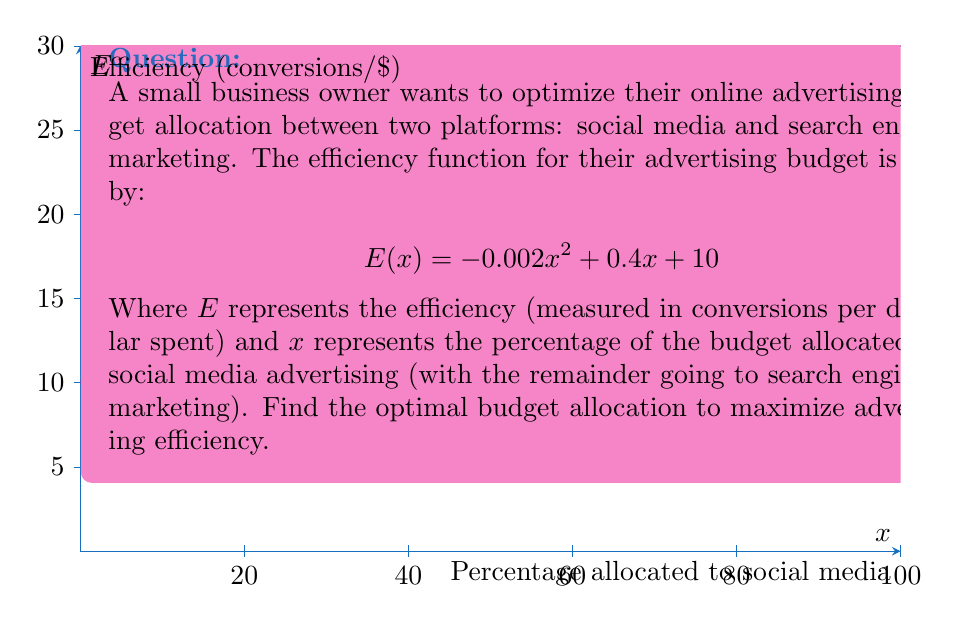Give your solution to this math problem. To find the maximum efficiency point, we need to find the vertex of the parabola described by the efficiency function. We can do this by following these steps:

1) The efficiency function is in the form of a quadratic equation:
   $$E(x) = -0.002x^2 + 0.4x + 10$$

2) For a quadratic function in the form $f(x) = ax^2 + bx + c$, the x-coordinate of the vertex is given by $x = -\frac{b}{2a}$.

3) In our case:
   $a = -0.002$
   $b = 0.4$

4) Plugging these values into the formula:
   $$x = -\frac{0.4}{2(-0.002)} = -\frac{0.4}{-0.004} = 100$$

5) This means the efficiency is maximized when 100% of the budget is allocated to social media advertising.

6) To verify, we can calculate the second derivative:
   $$E'(x) = -0.004x + 0.4$$
   $$E''(x) = -0.004$$

   Since $E''(x)$ is negative, this confirms we've found a maximum.

7) The maximum efficiency can be calculated by plugging x = 100 into the original function:
   $$E(100) = -0.002(100)^2 + 0.4(100) + 10 = 30$$

Therefore, the optimal budget allocation is 100% to social media advertising, resulting in a maximum efficiency of 30 conversions per dollar spent.
Answer: 100% social media advertising; 30 conversions/dollar 